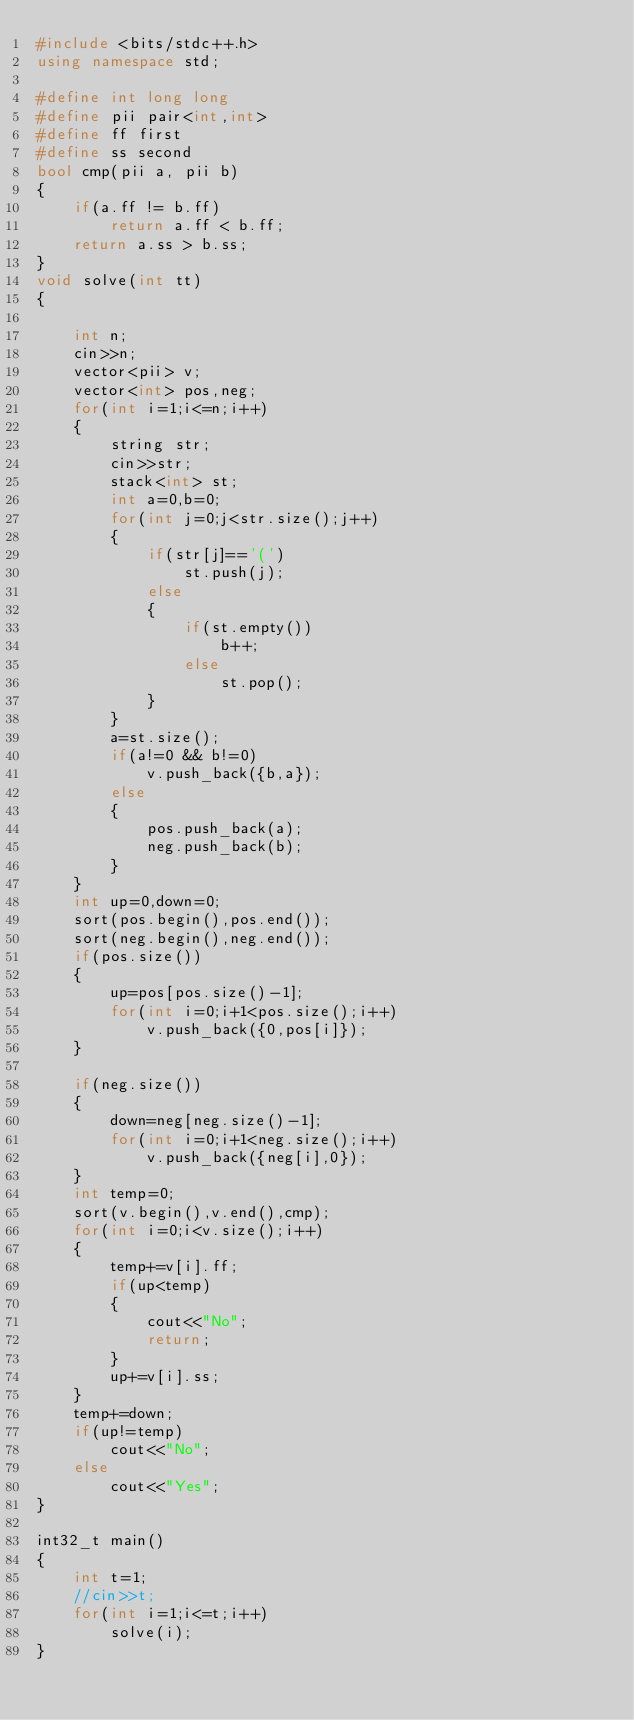Convert code to text. <code><loc_0><loc_0><loc_500><loc_500><_C++_>#include <bits/stdc++.h>
using namespace std;

#define int long long
#define pii pair<int,int>
#define ff first
#define ss second
bool cmp(pii a, pii b)
{
	if(a.ff != b.ff)
		return a.ff < b.ff;
	return a.ss > b.ss;
}
void solve(int tt)
{
    
    int n;
    cin>>n;
    vector<pii> v;
    vector<int> pos,neg;
    for(int i=1;i<=n;i++)
    {
        string str;
        cin>>str;
        stack<int> st;
        int a=0,b=0;
        for(int j=0;j<str.size();j++)
        {
            if(str[j]=='(')
                st.push(j);
            else
            {
                if(st.empty())
                    b++; 
                else
                    st.pop();
            }
        }
        a=st.size();
        if(a!=0 && b!=0)
            v.push_back({b,a});
        else
        {
            pos.push_back(a);
            neg.push_back(b);
        }
    }
    int up=0,down=0;
    sort(pos.begin(),pos.end());
    sort(neg.begin(),neg.end());
    if(pos.size())
    {
        up=pos[pos.size()-1];
        for(int i=0;i+1<pos.size();i++)
            v.push_back({0,pos[i]});
    }
    
    if(neg.size())
    {
        down=neg[neg.size()-1];
        for(int i=0;i+1<neg.size();i++)
            v.push_back({neg[i],0});
    }
    int temp=0;
    sort(v.begin(),v.end(),cmp);
    for(int i=0;i<v.size();i++)
    {
        temp+=v[i].ff;
        if(up<temp)
        {
            cout<<"No";
            return;
        }
        up+=v[i].ss;
    }
    temp+=down;
    if(up!=temp)
        cout<<"No";
    else
        cout<<"Yes";
}

int32_t main()
{
    int t=1;
    //cin>>t;
    for(int i=1;i<=t;i++)
        solve(i);
}
</code> 